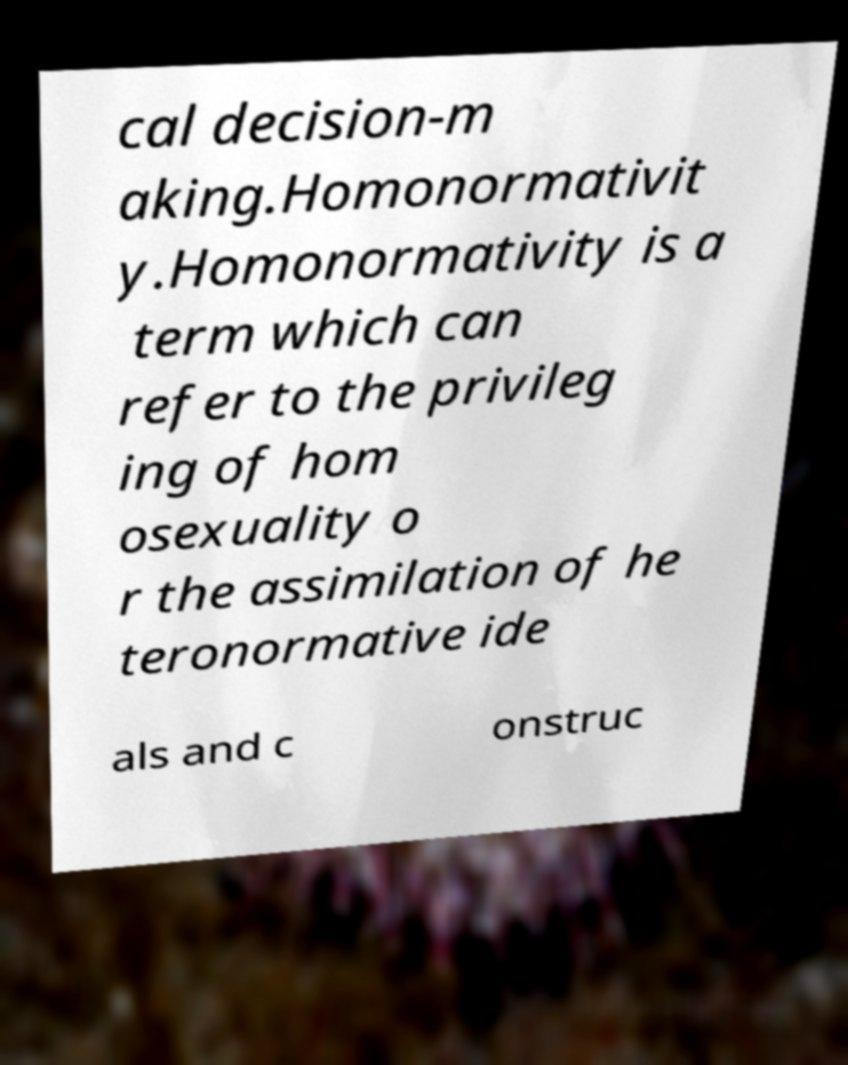There's text embedded in this image that I need extracted. Can you transcribe it verbatim? cal decision-m aking.Homonormativit y.Homonormativity is a term which can refer to the privileg ing of hom osexuality o r the assimilation of he teronormative ide als and c onstruc 